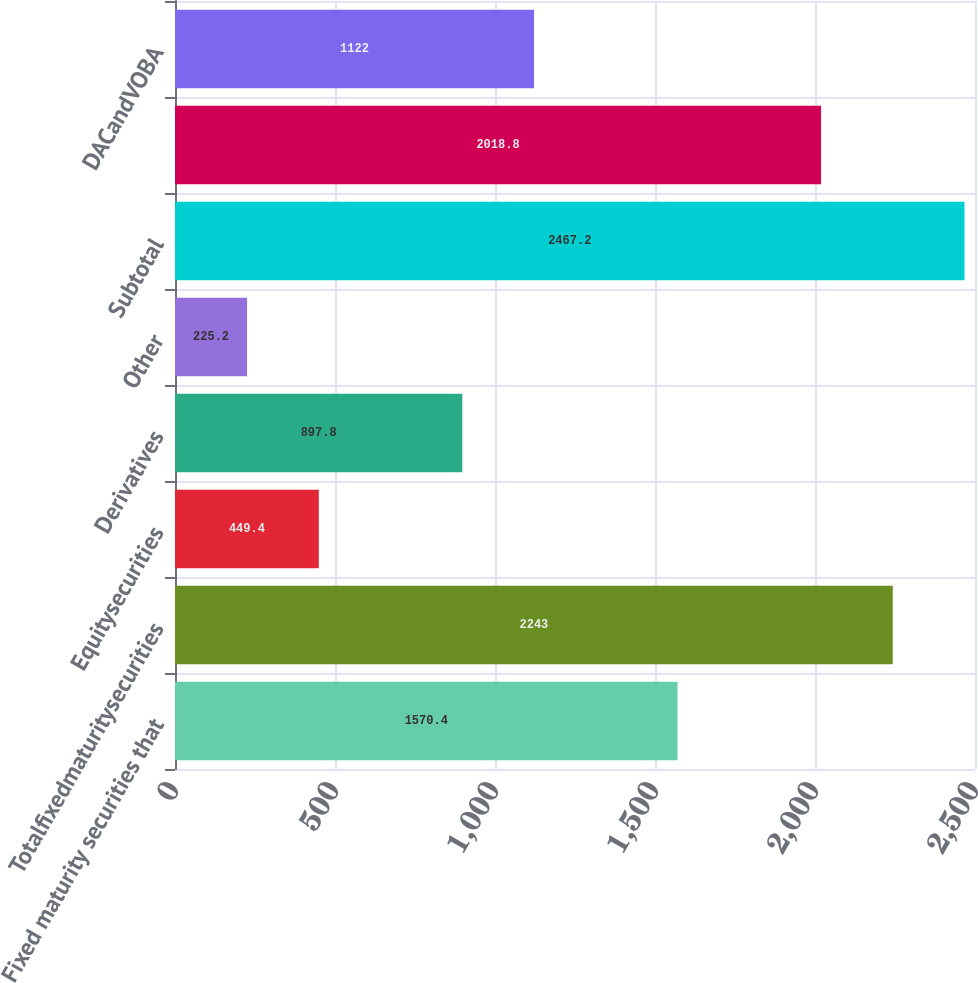<chart> <loc_0><loc_0><loc_500><loc_500><bar_chart><fcel>Fixed maturity securities that<fcel>Totalfixedmaturitysecurities<fcel>Equitysecurities<fcel>Derivatives<fcel>Other<fcel>Subtotal<fcel>Unnamed: 6<fcel>DACandVOBA<nl><fcel>1570.4<fcel>2243<fcel>449.4<fcel>897.8<fcel>225.2<fcel>2467.2<fcel>2018.8<fcel>1122<nl></chart> 